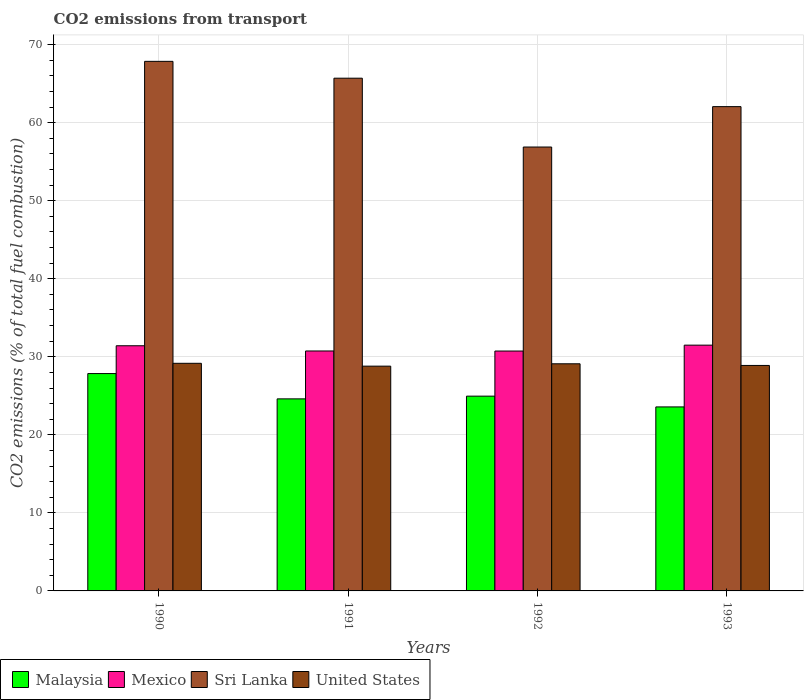How many different coloured bars are there?
Keep it short and to the point. 4. Are the number of bars per tick equal to the number of legend labels?
Give a very brief answer. Yes. Are the number of bars on each tick of the X-axis equal?
Offer a terse response. Yes. How many bars are there on the 1st tick from the right?
Give a very brief answer. 4. What is the total CO2 emitted in Malaysia in 1993?
Provide a succinct answer. 23.58. Across all years, what is the maximum total CO2 emitted in Sri Lanka?
Make the answer very short. 67.86. Across all years, what is the minimum total CO2 emitted in Sri Lanka?
Your response must be concise. 56.88. In which year was the total CO2 emitted in Malaysia maximum?
Keep it short and to the point. 1990. What is the total total CO2 emitted in Mexico in the graph?
Ensure brevity in your answer.  124.39. What is the difference between the total CO2 emitted in United States in 1990 and that in 1991?
Ensure brevity in your answer.  0.36. What is the difference between the total CO2 emitted in Malaysia in 1993 and the total CO2 emitted in Sri Lanka in 1990?
Provide a short and direct response. -44.28. What is the average total CO2 emitted in Mexico per year?
Provide a succinct answer. 31.1. In the year 1993, what is the difference between the total CO2 emitted in United States and total CO2 emitted in Mexico?
Offer a terse response. -2.6. In how many years, is the total CO2 emitted in United States greater than 2?
Your answer should be very brief. 4. What is the ratio of the total CO2 emitted in Mexico in 1992 to that in 1993?
Offer a terse response. 0.98. Is the total CO2 emitted in Mexico in 1990 less than that in 1992?
Your answer should be very brief. No. Is the difference between the total CO2 emitted in United States in 1991 and 1992 greater than the difference between the total CO2 emitted in Mexico in 1991 and 1992?
Give a very brief answer. No. What is the difference between the highest and the second highest total CO2 emitted in Sri Lanka?
Your response must be concise. 2.16. What is the difference between the highest and the lowest total CO2 emitted in Mexico?
Provide a succinct answer. 0.76. Is the sum of the total CO2 emitted in Mexico in 1992 and 1993 greater than the maximum total CO2 emitted in United States across all years?
Give a very brief answer. Yes. What does the 4th bar from the left in 1992 represents?
Provide a succinct answer. United States. What does the 1st bar from the right in 1992 represents?
Keep it short and to the point. United States. Is it the case that in every year, the sum of the total CO2 emitted in Malaysia and total CO2 emitted in Mexico is greater than the total CO2 emitted in Sri Lanka?
Provide a succinct answer. No. How many bars are there?
Your answer should be very brief. 16. Are all the bars in the graph horizontal?
Ensure brevity in your answer.  No. What is the difference between two consecutive major ticks on the Y-axis?
Provide a succinct answer. 10. Are the values on the major ticks of Y-axis written in scientific E-notation?
Make the answer very short. No. Does the graph contain any zero values?
Provide a short and direct response. No. Does the graph contain grids?
Make the answer very short. Yes. Where does the legend appear in the graph?
Offer a terse response. Bottom left. How are the legend labels stacked?
Give a very brief answer. Horizontal. What is the title of the graph?
Provide a succinct answer. CO2 emissions from transport. What is the label or title of the X-axis?
Ensure brevity in your answer.  Years. What is the label or title of the Y-axis?
Your answer should be compact. CO2 emissions (% of total fuel combustion). What is the CO2 emissions (% of total fuel combustion) in Malaysia in 1990?
Keep it short and to the point. 27.85. What is the CO2 emissions (% of total fuel combustion) of Mexico in 1990?
Your answer should be very brief. 31.41. What is the CO2 emissions (% of total fuel combustion) of Sri Lanka in 1990?
Your response must be concise. 67.86. What is the CO2 emissions (% of total fuel combustion) of United States in 1990?
Your answer should be very brief. 29.17. What is the CO2 emissions (% of total fuel combustion) of Malaysia in 1991?
Make the answer very short. 24.61. What is the CO2 emissions (% of total fuel combustion) of Mexico in 1991?
Make the answer very short. 30.75. What is the CO2 emissions (% of total fuel combustion) of Sri Lanka in 1991?
Give a very brief answer. 65.7. What is the CO2 emissions (% of total fuel combustion) of United States in 1991?
Keep it short and to the point. 28.8. What is the CO2 emissions (% of total fuel combustion) in Malaysia in 1992?
Ensure brevity in your answer.  24.96. What is the CO2 emissions (% of total fuel combustion) in Mexico in 1992?
Give a very brief answer. 30.74. What is the CO2 emissions (% of total fuel combustion) in Sri Lanka in 1992?
Offer a very short reply. 56.88. What is the CO2 emissions (% of total fuel combustion) in United States in 1992?
Give a very brief answer. 29.1. What is the CO2 emissions (% of total fuel combustion) of Malaysia in 1993?
Your answer should be very brief. 23.58. What is the CO2 emissions (% of total fuel combustion) in Mexico in 1993?
Make the answer very short. 31.49. What is the CO2 emissions (% of total fuel combustion) in Sri Lanka in 1993?
Offer a very short reply. 62.05. What is the CO2 emissions (% of total fuel combustion) of United States in 1993?
Give a very brief answer. 28.89. Across all years, what is the maximum CO2 emissions (% of total fuel combustion) of Malaysia?
Your answer should be compact. 27.85. Across all years, what is the maximum CO2 emissions (% of total fuel combustion) in Mexico?
Your answer should be very brief. 31.49. Across all years, what is the maximum CO2 emissions (% of total fuel combustion) of Sri Lanka?
Provide a short and direct response. 67.86. Across all years, what is the maximum CO2 emissions (% of total fuel combustion) of United States?
Ensure brevity in your answer.  29.17. Across all years, what is the minimum CO2 emissions (% of total fuel combustion) of Malaysia?
Your response must be concise. 23.58. Across all years, what is the minimum CO2 emissions (% of total fuel combustion) of Mexico?
Provide a succinct answer. 30.74. Across all years, what is the minimum CO2 emissions (% of total fuel combustion) of Sri Lanka?
Your answer should be compact. 56.88. Across all years, what is the minimum CO2 emissions (% of total fuel combustion) of United States?
Your answer should be compact. 28.8. What is the total CO2 emissions (% of total fuel combustion) of Malaysia in the graph?
Make the answer very short. 101. What is the total CO2 emissions (% of total fuel combustion) of Mexico in the graph?
Offer a terse response. 124.39. What is the total CO2 emissions (% of total fuel combustion) of Sri Lanka in the graph?
Offer a very short reply. 252.49. What is the total CO2 emissions (% of total fuel combustion) in United States in the graph?
Make the answer very short. 115.96. What is the difference between the CO2 emissions (% of total fuel combustion) of Malaysia in 1990 and that in 1991?
Keep it short and to the point. 3.24. What is the difference between the CO2 emissions (% of total fuel combustion) of Mexico in 1990 and that in 1991?
Give a very brief answer. 0.67. What is the difference between the CO2 emissions (% of total fuel combustion) in Sri Lanka in 1990 and that in 1991?
Provide a succinct answer. 2.16. What is the difference between the CO2 emissions (% of total fuel combustion) of United States in 1990 and that in 1991?
Your response must be concise. 0.36. What is the difference between the CO2 emissions (% of total fuel combustion) of Malaysia in 1990 and that in 1992?
Give a very brief answer. 2.89. What is the difference between the CO2 emissions (% of total fuel combustion) of Mexico in 1990 and that in 1992?
Give a very brief answer. 0.68. What is the difference between the CO2 emissions (% of total fuel combustion) of Sri Lanka in 1990 and that in 1992?
Provide a short and direct response. 10.98. What is the difference between the CO2 emissions (% of total fuel combustion) in United States in 1990 and that in 1992?
Your answer should be very brief. 0.06. What is the difference between the CO2 emissions (% of total fuel combustion) of Malaysia in 1990 and that in 1993?
Keep it short and to the point. 4.27. What is the difference between the CO2 emissions (% of total fuel combustion) in Mexico in 1990 and that in 1993?
Ensure brevity in your answer.  -0.08. What is the difference between the CO2 emissions (% of total fuel combustion) of Sri Lanka in 1990 and that in 1993?
Give a very brief answer. 5.8. What is the difference between the CO2 emissions (% of total fuel combustion) of United States in 1990 and that in 1993?
Your answer should be very brief. 0.27. What is the difference between the CO2 emissions (% of total fuel combustion) of Malaysia in 1991 and that in 1992?
Provide a succinct answer. -0.35. What is the difference between the CO2 emissions (% of total fuel combustion) in Mexico in 1991 and that in 1992?
Offer a terse response. 0.01. What is the difference between the CO2 emissions (% of total fuel combustion) of Sri Lanka in 1991 and that in 1992?
Ensure brevity in your answer.  8.82. What is the difference between the CO2 emissions (% of total fuel combustion) of United States in 1991 and that in 1992?
Offer a very short reply. -0.3. What is the difference between the CO2 emissions (% of total fuel combustion) of Malaysia in 1991 and that in 1993?
Give a very brief answer. 1.03. What is the difference between the CO2 emissions (% of total fuel combustion) of Mexico in 1991 and that in 1993?
Provide a short and direct response. -0.75. What is the difference between the CO2 emissions (% of total fuel combustion) of Sri Lanka in 1991 and that in 1993?
Offer a terse response. 3.64. What is the difference between the CO2 emissions (% of total fuel combustion) in United States in 1991 and that in 1993?
Give a very brief answer. -0.09. What is the difference between the CO2 emissions (% of total fuel combustion) in Malaysia in 1992 and that in 1993?
Provide a short and direct response. 1.38. What is the difference between the CO2 emissions (% of total fuel combustion) of Mexico in 1992 and that in 1993?
Ensure brevity in your answer.  -0.76. What is the difference between the CO2 emissions (% of total fuel combustion) in Sri Lanka in 1992 and that in 1993?
Offer a terse response. -5.18. What is the difference between the CO2 emissions (% of total fuel combustion) of United States in 1992 and that in 1993?
Make the answer very short. 0.21. What is the difference between the CO2 emissions (% of total fuel combustion) of Malaysia in 1990 and the CO2 emissions (% of total fuel combustion) of Mexico in 1991?
Offer a terse response. -2.89. What is the difference between the CO2 emissions (% of total fuel combustion) of Malaysia in 1990 and the CO2 emissions (% of total fuel combustion) of Sri Lanka in 1991?
Offer a very short reply. -37.85. What is the difference between the CO2 emissions (% of total fuel combustion) of Malaysia in 1990 and the CO2 emissions (% of total fuel combustion) of United States in 1991?
Make the answer very short. -0.95. What is the difference between the CO2 emissions (% of total fuel combustion) of Mexico in 1990 and the CO2 emissions (% of total fuel combustion) of Sri Lanka in 1991?
Make the answer very short. -34.28. What is the difference between the CO2 emissions (% of total fuel combustion) of Mexico in 1990 and the CO2 emissions (% of total fuel combustion) of United States in 1991?
Your answer should be very brief. 2.61. What is the difference between the CO2 emissions (% of total fuel combustion) of Sri Lanka in 1990 and the CO2 emissions (% of total fuel combustion) of United States in 1991?
Your answer should be very brief. 39.06. What is the difference between the CO2 emissions (% of total fuel combustion) in Malaysia in 1990 and the CO2 emissions (% of total fuel combustion) in Mexico in 1992?
Ensure brevity in your answer.  -2.89. What is the difference between the CO2 emissions (% of total fuel combustion) in Malaysia in 1990 and the CO2 emissions (% of total fuel combustion) in Sri Lanka in 1992?
Your answer should be compact. -29.03. What is the difference between the CO2 emissions (% of total fuel combustion) in Malaysia in 1990 and the CO2 emissions (% of total fuel combustion) in United States in 1992?
Keep it short and to the point. -1.25. What is the difference between the CO2 emissions (% of total fuel combustion) of Mexico in 1990 and the CO2 emissions (% of total fuel combustion) of Sri Lanka in 1992?
Provide a short and direct response. -25.46. What is the difference between the CO2 emissions (% of total fuel combustion) of Mexico in 1990 and the CO2 emissions (% of total fuel combustion) of United States in 1992?
Your response must be concise. 2.31. What is the difference between the CO2 emissions (% of total fuel combustion) of Sri Lanka in 1990 and the CO2 emissions (% of total fuel combustion) of United States in 1992?
Make the answer very short. 38.75. What is the difference between the CO2 emissions (% of total fuel combustion) of Malaysia in 1990 and the CO2 emissions (% of total fuel combustion) of Mexico in 1993?
Offer a terse response. -3.64. What is the difference between the CO2 emissions (% of total fuel combustion) of Malaysia in 1990 and the CO2 emissions (% of total fuel combustion) of Sri Lanka in 1993?
Your answer should be very brief. -34.2. What is the difference between the CO2 emissions (% of total fuel combustion) in Malaysia in 1990 and the CO2 emissions (% of total fuel combustion) in United States in 1993?
Keep it short and to the point. -1.04. What is the difference between the CO2 emissions (% of total fuel combustion) of Mexico in 1990 and the CO2 emissions (% of total fuel combustion) of Sri Lanka in 1993?
Make the answer very short. -30.64. What is the difference between the CO2 emissions (% of total fuel combustion) in Mexico in 1990 and the CO2 emissions (% of total fuel combustion) in United States in 1993?
Provide a succinct answer. 2.52. What is the difference between the CO2 emissions (% of total fuel combustion) of Sri Lanka in 1990 and the CO2 emissions (% of total fuel combustion) of United States in 1993?
Ensure brevity in your answer.  38.96. What is the difference between the CO2 emissions (% of total fuel combustion) of Malaysia in 1991 and the CO2 emissions (% of total fuel combustion) of Mexico in 1992?
Your answer should be very brief. -6.13. What is the difference between the CO2 emissions (% of total fuel combustion) of Malaysia in 1991 and the CO2 emissions (% of total fuel combustion) of Sri Lanka in 1992?
Make the answer very short. -32.27. What is the difference between the CO2 emissions (% of total fuel combustion) in Malaysia in 1991 and the CO2 emissions (% of total fuel combustion) in United States in 1992?
Offer a very short reply. -4.5. What is the difference between the CO2 emissions (% of total fuel combustion) in Mexico in 1991 and the CO2 emissions (% of total fuel combustion) in Sri Lanka in 1992?
Your answer should be very brief. -26.13. What is the difference between the CO2 emissions (% of total fuel combustion) in Mexico in 1991 and the CO2 emissions (% of total fuel combustion) in United States in 1992?
Keep it short and to the point. 1.64. What is the difference between the CO2 emissions (% of total fuel combustion) in Sri Lanka in 1991 and the CO2 emissions (% of total fuel combustion) in United States in 1992?
Provide a short and direct response. 36.6. What is the difference between the CO2 emissions (% of total fuel combustion) of Malaysia in 1991 and the CO2 emissions (% of total fuel combustion) of Mexico in 1993?
Offer a very short reply. -6.88. What is the difference between the CO2 emissions (% of total fuel combustion) of Malaysia in 1991 and the CO2 emissions (% of total fuel combustion) of Sri Lanka in 1993?
Give a very brief answer. -37.45. What is the difference between the CO2 emissions (% of total fuel combustion) in Malaysia in 1991 and the CO2 emissions (% of total fuel combustion) in United States in 1993?
Keep it short and to the point. -4.28. What is the difference between the CO2 emissions (% of total fuel combustion) of Mexico in 1991 and the CO2 emissions (% of total fuel combustion) of Sri Lanka in 1993?
Your answer should be compact. -31.31. What is the difference between the CO2 emissions (% of total fuel combustion) of Mexico in 1991 and the CO2 emissions (% of total fuel combustion) of United States in 1993?
Provide a short and direct response. 1.85. What is the difference between the CO2 emissions (% of total fuel combustion) of Sri Lanka in 1991 and the CO2 emissions (% of total fuel combustion) of United States in 1993?
Offer a terse response. 36.81. What is the difference between the CO2 emissions (% of total fuel combustion) in Malaysia in 1992 and the CO2 emissions (% of total fuel combustion) in Mexico in 1993?
Offer a very short reply. -6.54. What is the difference between the CO2 emissions (% of total fuel combustion) in Malaysia in 1992 and the CO2 emissions (% of total fuel combustion) in Sri Lanka in 1993?
Provide a short and direct response. -37.1. What is the difference between the CO2 emissions (% of total fuel combustion) in Malaysia in 1992 and the CO2 emissions (% of total fuel combustion) in United States in 1993?
Ensure brevity in your answer.  -3.94. What is the difference between the CO2 emissions (% of total fuel combustion) in Mexico in 1992 and the CO2 emissions (% of total fuel combustion) in Sri Lanka in 1993?
Offer a very short reply. -31.32. What is the difference between the CO2 emissions (% of total fuel combustion) of Mexico in 1992 and the CO2 emissions (% of total fuel combustion) of United States in 1993?
Make the answer very short. 1.84. What is the difference between the CO2 emissions (% of total fuel combustion) in Sri Lanka in 1992 and the CO2 emissions (% of total fuel combustion) in United States in 1993?
Give a very brief answer. 27.99. What is the average CO2 emissions (% of total fuel combustion) in Malaysia per year?
Provide a succinct answer. 25.25. What is the average CO2 emissions (% of total fuel combustion) in Mexico per year?
Keep it short and to the point. 31.1. What is the average CO2 emissions (% of total fuel combustion) of Sri Lanka per year?
Make the answer very short. 63.12. What is the average CO2 emissions (% of total fuel combustion) in United States per year?
Offer a terse response. 28.99. In the year 1990, what is the difference between the CO2 emissions (% of total fuel combustion) in Malaysia and CO2 emissions (% of total fuel combustion) in Mexico?
Provide a short and direct response. -3.56. In the year 1990, what is the difference between the CO2 emissions (% of total fuel combustion) in Malaysia and CO2 emissions (% of total fuel combustion) in Sri Lanka?
Offer a terse response. -40.01. In the year 1990, what is the difference between the CO2 emissions (% of total fuel combustion) in Malaysia and CO2 emissions (% of total fuel combustion) in United States?
Offer a terse response. -1.31. In the year 1990, what is the difference between the CO2 emissions (% of total fuel combustion) of Mexico and CO2 emissions (% of total fuel combustion) of Sri Lanka?
Provide a short and direct response. -36.44. In the year 1990, what is the difference between the CO2 emissions (% of total fuel combustion) in Mexico and CO2 emissions (% of total fuel combustion) in United States?
Offer a terse response. 2.25. In the year 1990, what is the difference between the CO2 emissions (% of total fuel combustion) of Sri Lanka and CO2 emissions (% of total fuel combustion) of United States?
Ensure brevity in your answer.  38.69. In the year 1991, what is the difference between the CO2 emissions (% of total fuel combustion) in Malaysia and CO2 emissions (% of total fuel combustion) in Mexico?
Give a very brief answer. -6.14. In the year 1991, what is the difference between the CO2 emissions (% of total fuel combustion) of Malaysia and CO2 emissions (% of total fuel combustion) of Sri Lanka?
Provide a succinct answer. -41.09. In the year 1991, what is the difference between the CO2 emissions (% of total fuel combustion) of Malaysia and CO2 emissions (% of total fuel combustion) of United States?
Ensure brevity in your answer.  -4.19. In the year 1991, what is the difference between the CO2 emissions (% of total fuel combustion) of Mexico and CO2 emissions (% of total fuel combustion) of Sri Lanka?
Provide a short and direct response. -34.95. In the year 1991, what is the difference between the CO2 emissions (% of total fuel combustion) of Mexico and CO2 emissions (% of total fuel combustion) of United States?
Provide a succinct answer. 1.94. In the year 1991, what is the difference between the CO2 emissions (% of total fuel combustion) in Sri Lanka and CO2 emissions (% of total fuel combustion) in United States?
Ensure brevity in your answer.  36.9. In the year 1992, what is the difference between the CO2 emissions (% of total fuel combustion) of Malaysia and CO2 emissions (% of total fuel combustion) of Mexico?
Offer a terse response. -5.78. In the year 1992, what is the difference between the CO2 emissions (% of total fuel combustion) of Malaysia and CO2 emissions (% of total fuel combustion) of Sri Lanka?
Give a very brief answer. -31.92. In the year 1992, what is the difference between the CO2 emissions (% of total fuel combustion) in Malaysia and CO2 emissions (% of total fuel combustion) in United States?
Offer a terse response. -4.15. In the year 1992, what is the difference between the CO2 emissions (% of total fuel combustion) of Mexico and CO2 emissions (% of total fuel combustion) of Sri Lanka?
Provide a short and direct response. -26.14. In the year 1992, what is the difference between the CO2 emissions (% of total fuel combustion) of Mexico and CO2 emissions (% of total fuel combustion) of United States?
Offer a terse response. 1.63. In the year 1992, what is the difference between the CO2 emissions (% of total fuel combustion) of Sri Lanka and CO2 emissions (% of total fuel combustion) of United States?
Provide a short and direct response. 27.77. In the year 1993, what is the difference between the CO2 emissions (% of total fuel combustion) in Malaysia and CO2 emissions (% of total fuel combustion) in Mexico?
Your answer should be compact. -7.92. In the year 1993, what is the difference between the CO2 emissions (% of total fuel combustion) of Malaysia and CO2 emissions (% of total fuel combustion) of Sri Lanka?
Provide a succinct answer. -38.48. In the year 1993, what is the difference between the CO2 emissions (% of total fuel combustion) of Malaysia and CO2 emissions (% of total fuel combustion) of United States?
Your answer should be very brief. -5.32. In the year 1993, what is the difference between the CO2 emissions (% of total fuel combustion) in Mexico and CO2 emissions (% of total fuel combustion) in Sri Lanka?
Offer a very short reply. -30.56. In the year 1993, what is the difference between the CO2 emissions (% of total fuel combustion) in Mexico and CO2 emissions (% of total fuel combustion) in United States?
Keep it short and to the point. 2.6. In the year 1993, what is the difference between the CO2 emissions (% of total fuel combustion) in Sri Lanka and CO2 emissions (% of total fuel combustion) in United States?
Give a very brief answer. 33.16. What is the ratio of the CO2 emissions (% of total fuel combustion) of Malaysia in 1990 to that in 1991?
Ensure brevity in your answer.  1.13. What is the ratio of the CO2 emissions (% of total fuel combustion) in Mexico in 1990 to that in 1991?
Offer a very short reply. 1.02. What is the ratio of the CO2 emissions (% of total fuel combustion) of Sri Lanka in 1990 to that in 1991?
Ensure brevity in your answer.  1.03. What is the ratio of the CO2 emissions (% of total fuel combustion) of United States in 1990 to that in 1991?
Provide a succinct answer. 1.01. What is the ratio of the CO2 emissions (% of total fuel combustion) of Malaysia in 1990 to that in 1992?
Offer a terse response. 1.12. What is the ratio of the CO2 emissions (% of total fuel combustion) in Mexico in 1990 to that in 1992?
Your answer should be compact. 1.02. What is the ratio of the CO2 emissions (% of total fuel combustion) in Sri Lanka in 1990 to that in 1992?
Provide a short and direct response. 1.19. What is the ratio of the CO2 emissions (% of total fuel combustion) in United States in 1990 to that in 1992?
Your answer should be very brief. 1. What is the ratio of the CO2 emissions (% of total fuel combustion) of Malaysia in 1990 to that in 1993?
Offer a very short reply. 1.18. What is the ratio of the CO2 emissions (% of total fuel combustion) of Mexico in 1990 to that in 1993?
Provide a succinct answer. 1. What is the ratio of the CO2 emissions (% of total fuel combustion) in Sri Lanka in 1990 to that in 1993?
Keep it short and to the point. 1.09. What is the ratio of the CO2 emissions (% of total fuel combustion) of United States in 1990 to that in 1993?
Your response must be concise. 1.01. What is the ratio of the CO2 emissions (% of total fuel combustion) of Mexico in 1991 to that in 1992?
Provide a short and direct response. 1. What is the ratio of the CO2 emissions (% of total fuel combustion) in Sri Lanka in 1991 to that in 1992?
Keep it short and to the point. 1.16. What is the ratio of the CO2 emissions (% of total fuel combustion) of Malaysia in 1991 to that in 1993?
Your answer should be very brief. 1.04. What is the ratio of the CO2 emissions (% of total fuel combustion) in Mexico in 1991 to that in 1993?
Give a very brief answer. 0.98. What is the ratio of the CO2 emissions (% of total fuel combustion) in Sri Lanka in 1991 to that in 1993?
Provide a short and direct response. 1.06. What is the ratio of the CO2 emissions (% of total fuel combustion) in Malaysia in 1992 to that in 1993?
Your answer should be compact. 1.06. What is the ratio of the CO2 emissions (% of total fuel combustion) of Sri Lanka in 1992 to that in 1993?
Provide a succinct answer. 0.92. What is the ratio of the CO2 emissions (% of total fuel combustion) of United States in 1992 to that in 1993?
Your answer should be very brief. 1.01. What is the difference between the highest and the second highest CO2 emissions (% of total fuel combustion) of Malaysia?
Give a very brief answer. 2.89. What is the difference between the highest and the second highest CO2 emissions (% of total fuel combustion) of Mexico?
Provide a succinct answer. 0.08. What is the difference between the highest and the second highest CO2 emissions (% of total fuel combustion) in Sri Lanka?
Offer a very short reply. 2.16. What is the difference between the highest and the second highest CO2 emissions (% of total fuel combustion) in United States?
Give a very brief answer. 0.06. What is the difference between the highest and the lowest CO2 emissions (% of total fuel combustion) of Malaysia?
Offer a very short reply. 4.27. What is the difference between the highest and the lowest CO2 emissions (% of total fuel combustion) of Mexico?
Offer a terse response. 0.76. What is the difference between the highest and the lowest CO2 emissions (% of total fuel combustion) of Sri Lanka?
Your answer should be compact. 10.98. What is the difference between the highest and the lowest CO2 emissions (% of total fuel combustion) of United States?
Your answer should be very brief. 0.36. 